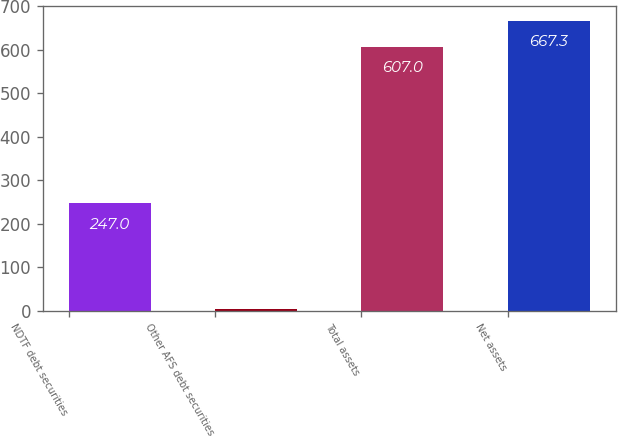<chart> <loc_0><loc_0><loc_500><loc_500><bar_chart><fcel>NDTF debt securities<fcel>Other AFS debt securities<fcel>Total assets<fcel>Net assets<nl><fcel>247<fcel>4<fcel>607<fcel>667.3<nl></chart> 